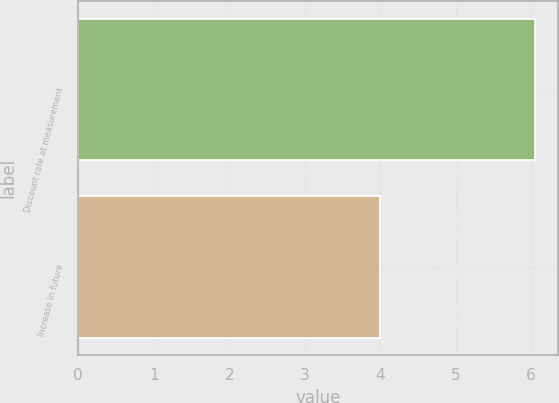<chart> <loc_0><loc_0><loc_500><loc_500><bar_chart><fcel>Discount rate at measurement<fcel>Increase in future<nl><fcel>6.05<fcel>4<nl></chart> 